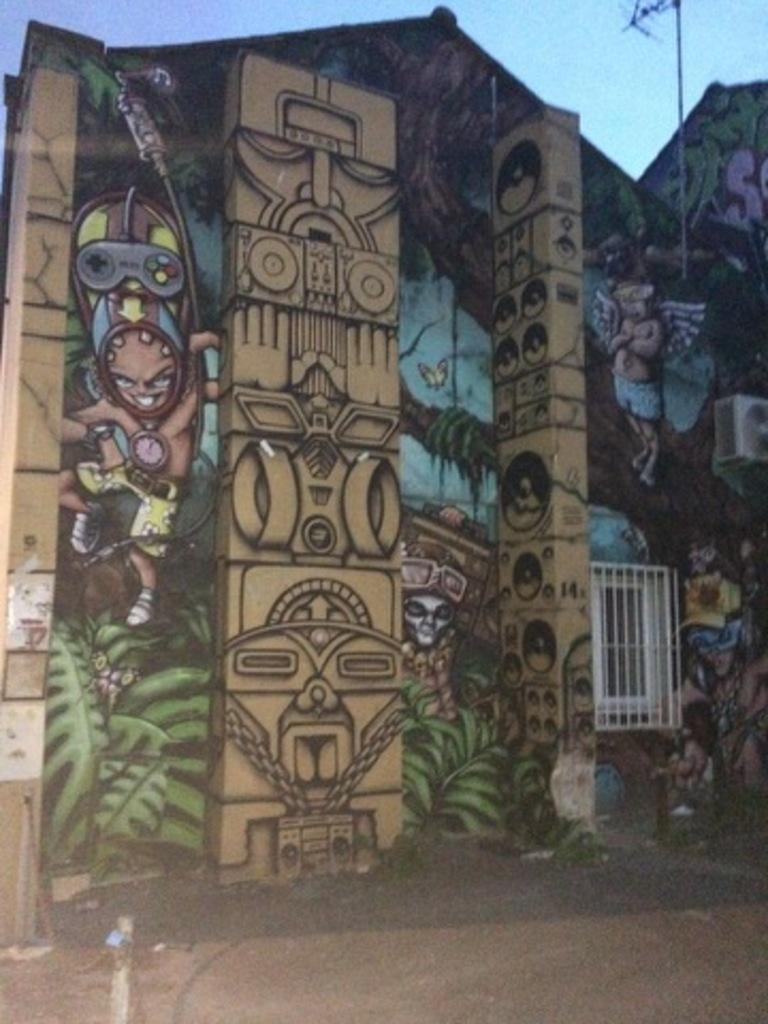What type of structure is present in the image? There is a building in the image. What can be seen on the wall of the building? There is graffiti on the wall of the building. What is visible on top of the building? There is an antenna visible in the image. What color is the sky in the image? The sky is blue in the image. What type of sheet is covering the crook in the image? There is no sheet or crook present in the image. What curve can be seen in the image? There is no curve mentioned in the provided facts, so we cannot answer this question based on the image. 